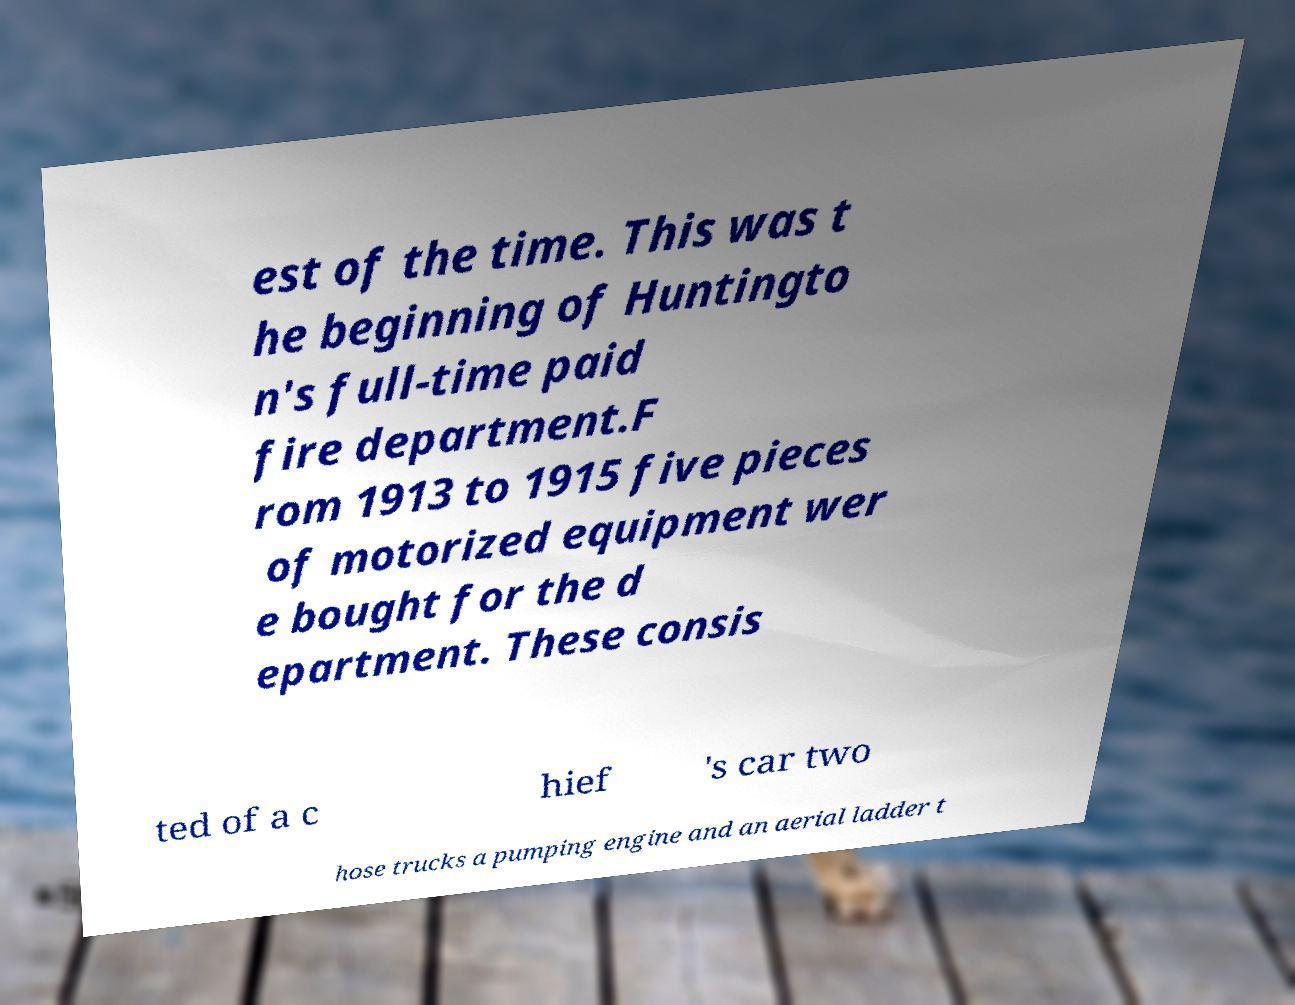There's text embedded in this image that I need extracted. Can you transcribe it verbatim? est of the time. This was t he beginning of Huntingto n's full-time paid fire department.F rom 1913 to 1915 five pieces of motorized equipment wer e bought for the d epartment. These consis ted of a c hief 's car two hose trucks a pumping engine and an aerial ladder t 